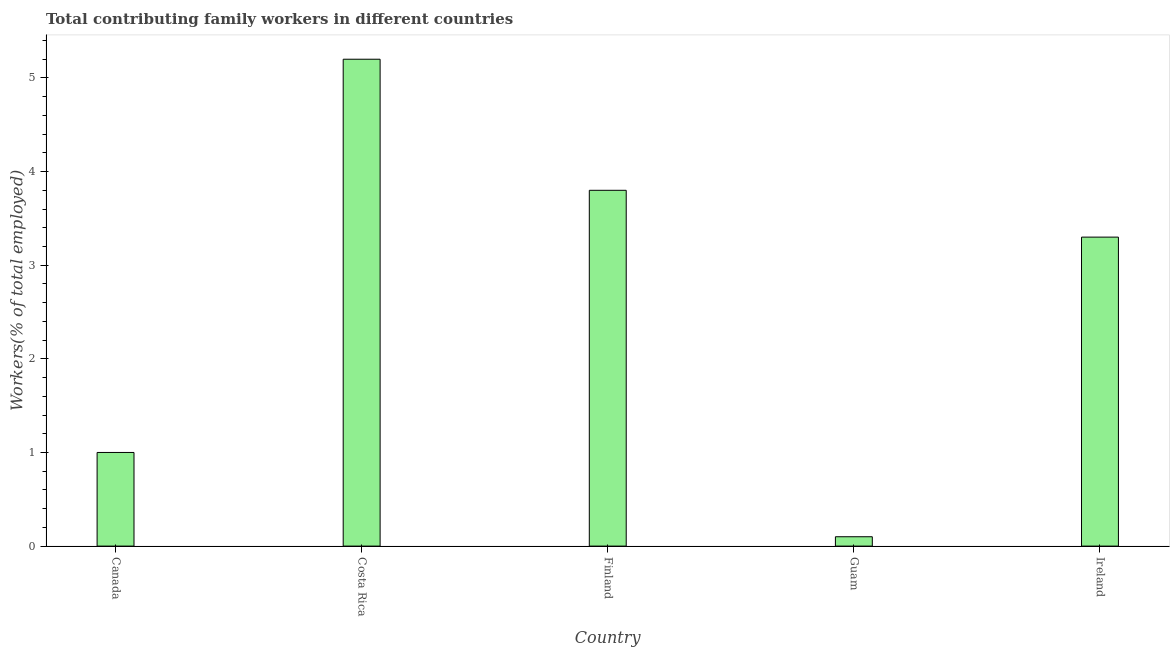Does the graph contain grids?
Provide a short and direct response. No. What is the title of the graph?
Make the answer very short. Total contributing family workers in different countries. What is the label or title of the X-axis?
Offer a terse response. Country. What is the label or title of the Y-axis?
Your answer should be compact. Workers(% of total employed). What is the contributing family workers in Finland?
Your answer should be compact. 3.8. Across all countries, what is the maximum contributing family workers?
Ensure brevity in your answer.  5.2. Across all countries, what is the minimum contributing family workers?
Provide a short and direct response. 0.1. In which country was the contributing family workers minimum?
Make the answer very short. Guam. What is the sum of the contributing family workers?
Make the answer very short. 13.4. What is the average contributing family workers per country?
Your answer should be very brief. 2.68. What is the median contributing family workers?
Your answer should be compact. 3.3. In how many countries, is the contributing family workers greater than 2.2 %?
Your response must be concise. 3. Is the difference between the contributing family workers in Costa Rica and Guam greater than the difference between any two countries?
Provide a succinct answer. Yes. What is the difference between the highest and the second highest contributing family workers?
Ensure brevity in your answer.  1.4. Is the sum of the contributing family workers in Canada and Guam greater than the maximum contributing family workers across all countries?
Make the answer very short. No. What is the difference between the highest and the lowest contributing family workers?
Keep it short and to the point. 5.1. Are all the bars in the graph horizontal?
Your answer should be very brief. No. Are the values on the major ticks of Y-axis written in scientific E-notation?
Your response must be concise. No. What is the Workers(% of total employed) of Canada?
Your response must be concise. 1. What is the Workers(% of total employed) in Costa Rica?
Your response must be concise. 5.2. What is the Workers(% of total employed) of Finland?
Offer a very short reply. 3.8. What is the Workers(% of total employed) of Guam?
Provide a succinct answer. 0.1. What is the Workers(% of total employed) of Ireland?
Give a very brief answer. 3.3. What is the difference between the Workers(% of total employed) in Canada and Costa Rica?
Offer a very short reply. -4.2. What is the difference between the Workers(% of total employed) in Costa Rica and Finland?
Offer a terse response. 1.4. What is the difference between the Workers(% of total employed) in Costa Rica and Guam?
Provide a short and direct response. 5.1. What is the difference between the Workers(% of total employed) in Costa Rica and Ireland?
Offer a terse response. 1.9. What is the difference between the Workers(% of total employed) in Finland and Ireland?
Ensure brevity in your answer.  0.5. What is the difference between the Workers(% of total employed) in Guam and Ireland?
Your answer should be compact. -3.2. What is the ratio of the Workers(% of total employed) in Canada to that in Costa Rica?
Your response must be concise. 0.19. What is the ratio of the Workers(% of total employed) in Canada to that in Finland?
Keep it short and to the point. 0.26. What is the ratio of the Workers(% of total employed) in Canada to that in Ireland?
Keep it short and to the point. 0.3. What is the ratio of the Workers(% of total employed) in Costa Rica to that in Finland?
Give a very brief answer. 1.37. What is the ratio of the Workers(% of total employed) in Costa Rica to that in Guam?
Ensure brevity in your answer.  52. What is the ratio of the Workers(% of total employed) in Costa Rica to that in Ireland?
Make the answer very short. 1.58. What is the ratio of the Workers(% of total employed) in Finland to that in Guam?
Offer a very short reply. 38. What is the ratio of the Workers(% of total employed) in Finland to that in Ireland?
Offer a very short reply. 1.15. What is the ratio of the Workers(% of total employed) in Guam to that in Ireland?
Provide a succinct answer. 0.03. 